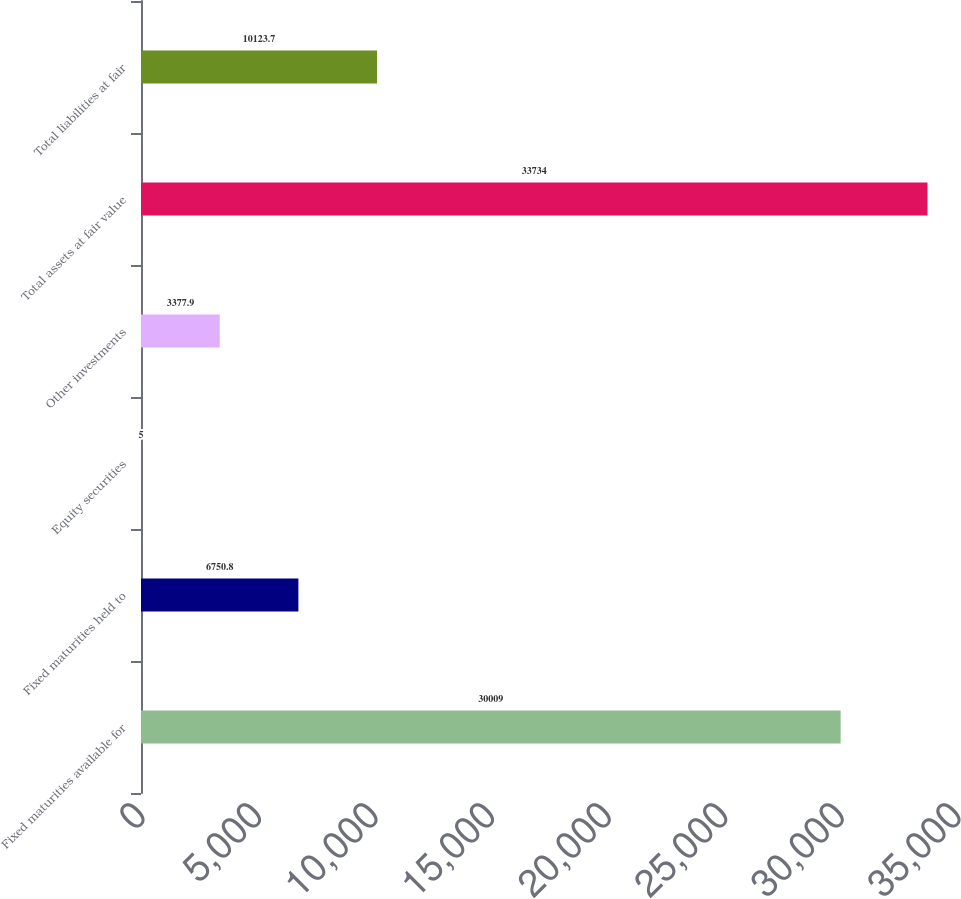Convert chart to OTSL. <chart><loc_0><loc_0><loc_500><loc_500><bar_chart><fcel>Fixed maturities available for<fcel>Fixed maturities held to<fcel>Equity securities<fcel>Other investments<fcel>Total assets at fair value<fcel>Total liabilities at fair<nl><fcel>30009<fcel>6750.8<fcel>5<fcel>3377.9<fcel>33734<fcel>10123.7<nl></chart> 